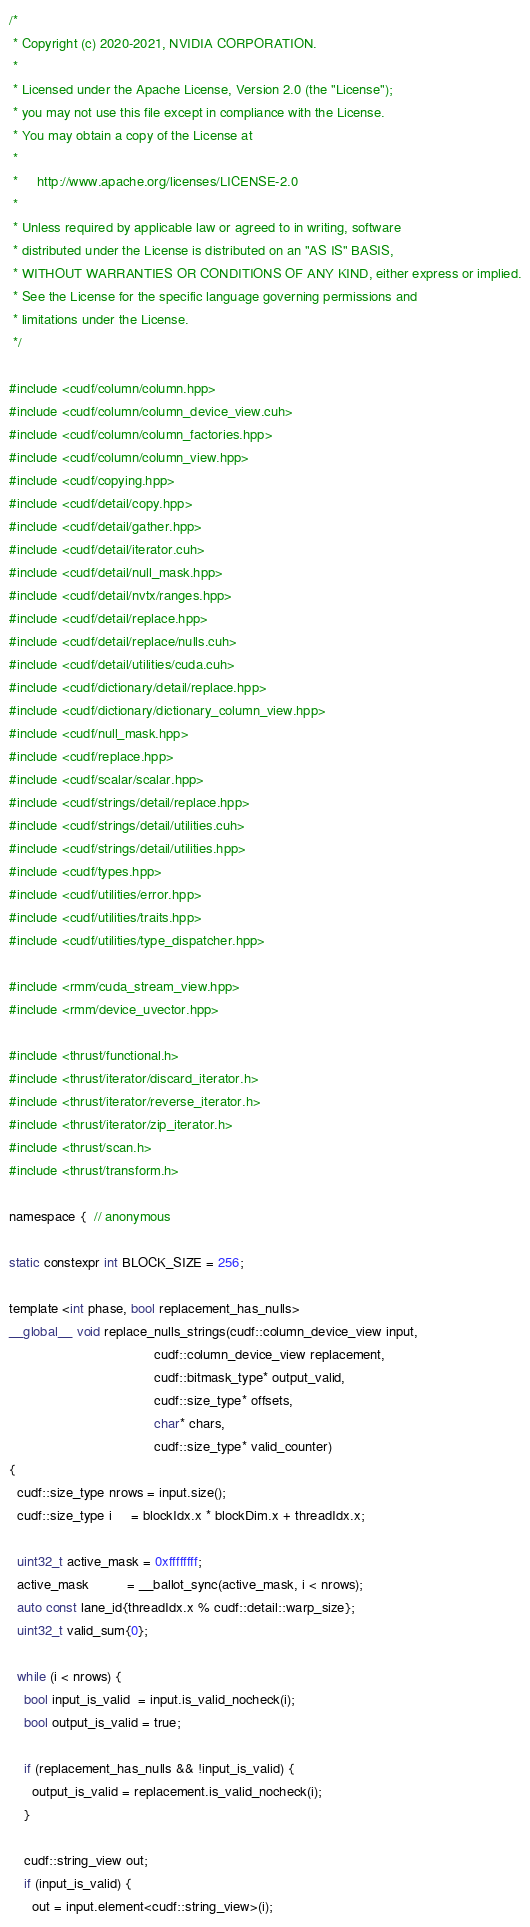Convert code to text. <code><loc_0><loc_0><loc_500><loc_500><_Cuda_>/*
 * Copyright (c) 2020-2021, NVIDIA CORPORATION.
 *
 * Licensed under the Apache License, Version 2.0 (the "License");
 * you may not use this file except in compliance with the License.
 * You may obtain a copy of the License at
 *
 *     http://www.apache.org/licenses/LICENSE-2.0
 *
 * Unless required by applicable law or agreed to in writing, software
 * distributed under the License is distributed on an "AS IS" BASIS,
 * WITHOUT WARRANTIES OR CONDITIONS OF ANY KIND, either express or implied.
 * See the License for the specific language governing permissions and
 * limitations under the License.
 */

#include <cudf/column/column.hpp>
#include <cudf/column/column_device_view.cuh>
#include <cudf/column/column_factories.hpp>
#include <cudf/column/column_view.hpp>
#include <cudf/copying.hpp>
#include <cudf/detail/copy.hpp>
#include <cudf/detail/gather.hpp>
#include <cudf/detail/iterator.cuh>
#include <cudf/detail/null_mask.hpp>
#include <cudf/detail/nvtx/ranges.hpp>
#include <cudf/detail/replace.hpp>
#include <cudf/detail/replace/nulls.cuh>
#include <cudf/detail/utilities/cuda.cuh>
#include <cudf/dictionary/detail/replace.hpp>
#include <cudf/dictionary/dictionary_column_view.hpp>
#include <cudf/null_mask.hpp>
#include <cudf/replace.hpp>
#include <cudf/scalar/scalar.hpp>
#include <cudf/strings/detail/replace.hpp>
#include <cudf/strings/detail/utilities.cuh>
#include <cudf/strings/detail/utilities.hpp>
#include <cudf/types.hpp>
#include <cudf/utilities/error.hpp>
#include <cudf/utilities/traits.hpp>
#include <cudf/utilities/type_dispatcher.hpp>

#include <rmm/cuda_stream_view.hpp>
#include <rmm/device_uvector.hpp>

#include <thrust/functional.h>
#include <thrust/iterator/discard_iterator.h>
#include <thrust/iterator/reverse_iterator.h>
#include <thrust/iterator/zip_iterator.h>
#include <thrust/scan.h>
#include <thrust/transform.h>

namespace {  // anonymous

static constexpr int BLOCK_SIZE = 256;

template <int phase, bool replacement_has_nulls>
__global__ void replace_nulls_strings(cudf::column_device_view input,
                                      cudf::column_device_view replacement,
                                      cudf::bitmask_type* output_valid,
                                      cudf::size_type* offsets,
                                      char* chars,
                                      cudf::size_type* valid_counter)
{
  cudf::size_type nrows = input.size();
  cudf::size_type i     = blockIdx.x * blockDim.x + threadIdx.x;

  uint32_t active_mask = 0xffffffff;
  active_mask          = __ballot_sync(active_mask, i < nrows);
  auto const lane_id{threadIdx.x % cudf::detail::warp_size};
  uint32_t valid_sum{0};

  while (i < nrows) {
    bool input_is_valid  = input.is_valid_nocheck(i);
    bool output_is_valid = true;

    if (replacement_has_nulls && !input_is_valid) {
      output_is_valid = replacement.is_valid_nocheck(i);
    }

    cudf::string_view out;
    if (input_is_valid) {
      out = input.element<cudf::string_view>(i);</code> 